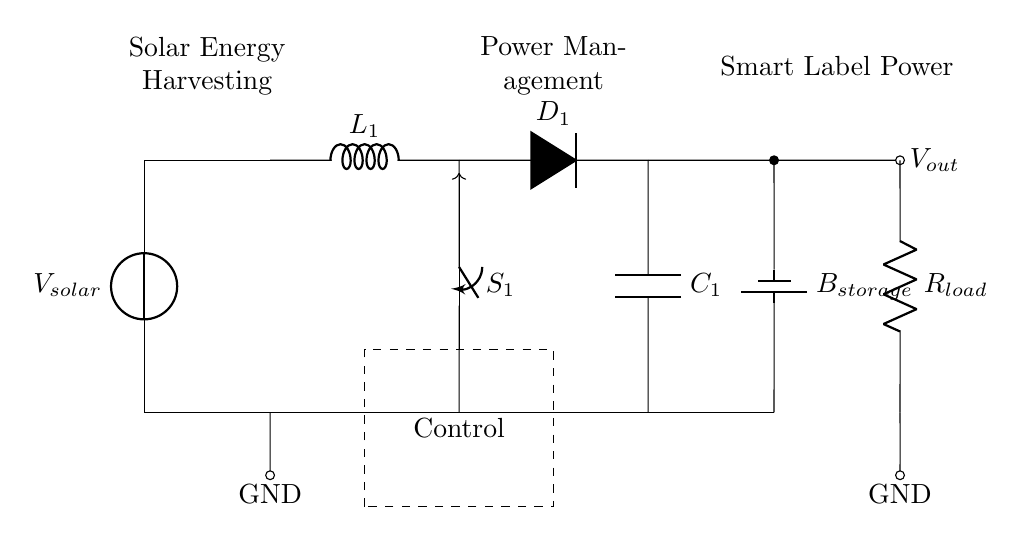What is the source of energy in this circuit? The source of energy is the solar cell, which converts sunlight into electrical energy to power the circuit.
Answer: solar cell What type of component is used for energy storage? The energy storage component is a battery, labeled as B_storage, which stores electrical energy for later use.
Answer: battery How many components are in the power management section? The power management section includes four components: an inductor, a switch, a diode, and a capacitor.
Answer: four What is the load connected to this circuit? The load connected is a resistor, labeled as R_load, which represents the smart label powered by the circuit.
Answer: resistor Why is a boost converter included in this circuit? A boost converter is included to increase the voltage level from the solar cell output to meet the requirements of the load, ensuring adequate power supply.
Answer: to increase voltage What does the control block do in the circuit? The control block regulates the operation of the boost converter and manages the overall energy flow to optimize efficiency for powering the smart label.
Answer: regulates operation What type of energy harvesting method is indicated in this circuit? The circuit uses solar energy harvesting, where energy from sunlight is converted into electrical energy for use in the smart label application.
Answer: solar energy harvesting 